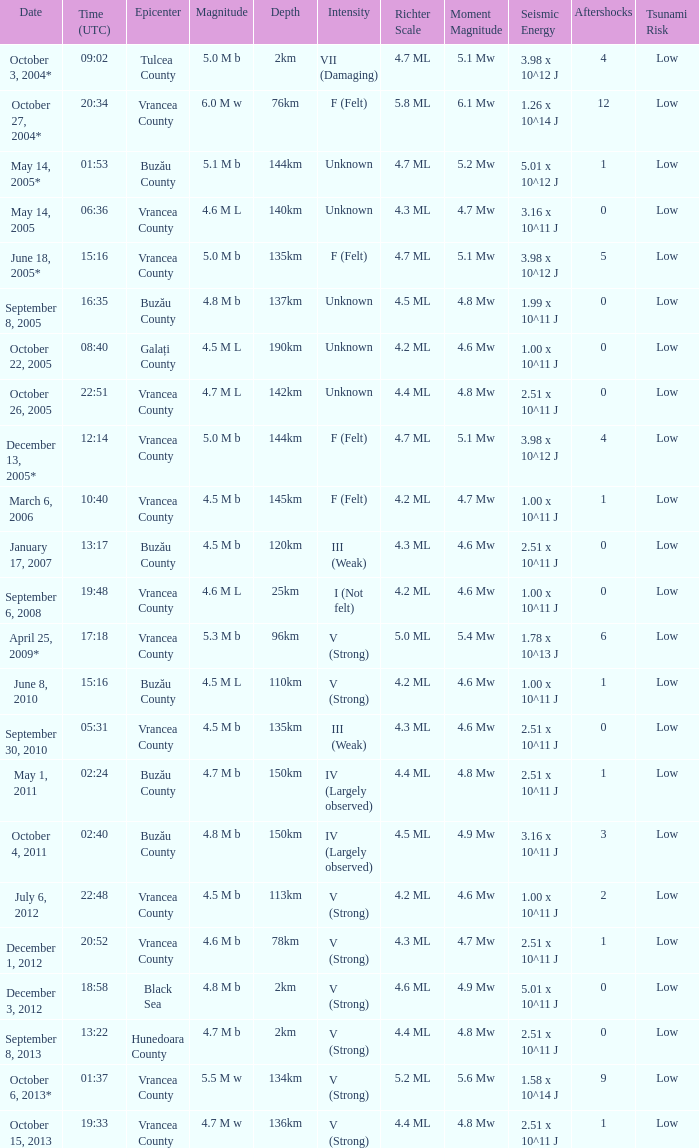What is the depth of the quake that occurred at 19:48? 25km. 